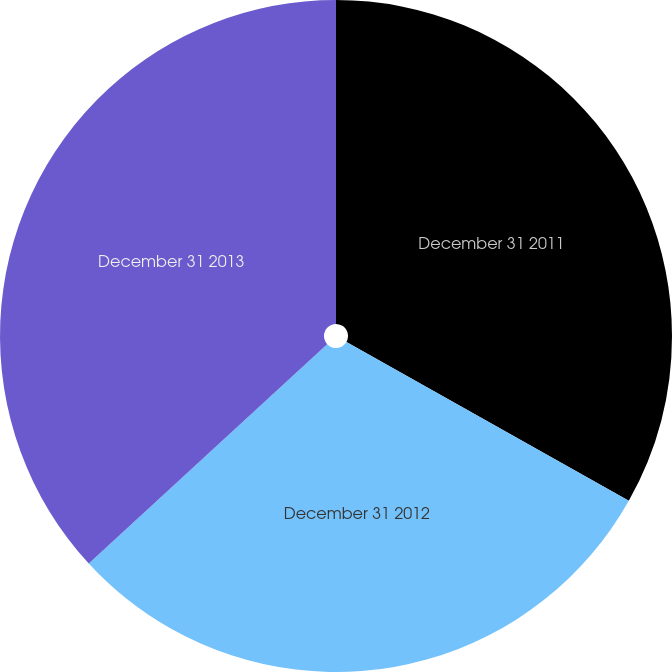Convert chart to OTSL. <chart><loc_0><loc_0><loc_500><loc_500><pie_chart><fcel>December 31 2011<fcel>December 31 2012<fcel>December 31 2013<nl><fcel>33.16%<fcel>30.0%<fcel>36.84%<nl></chart> 